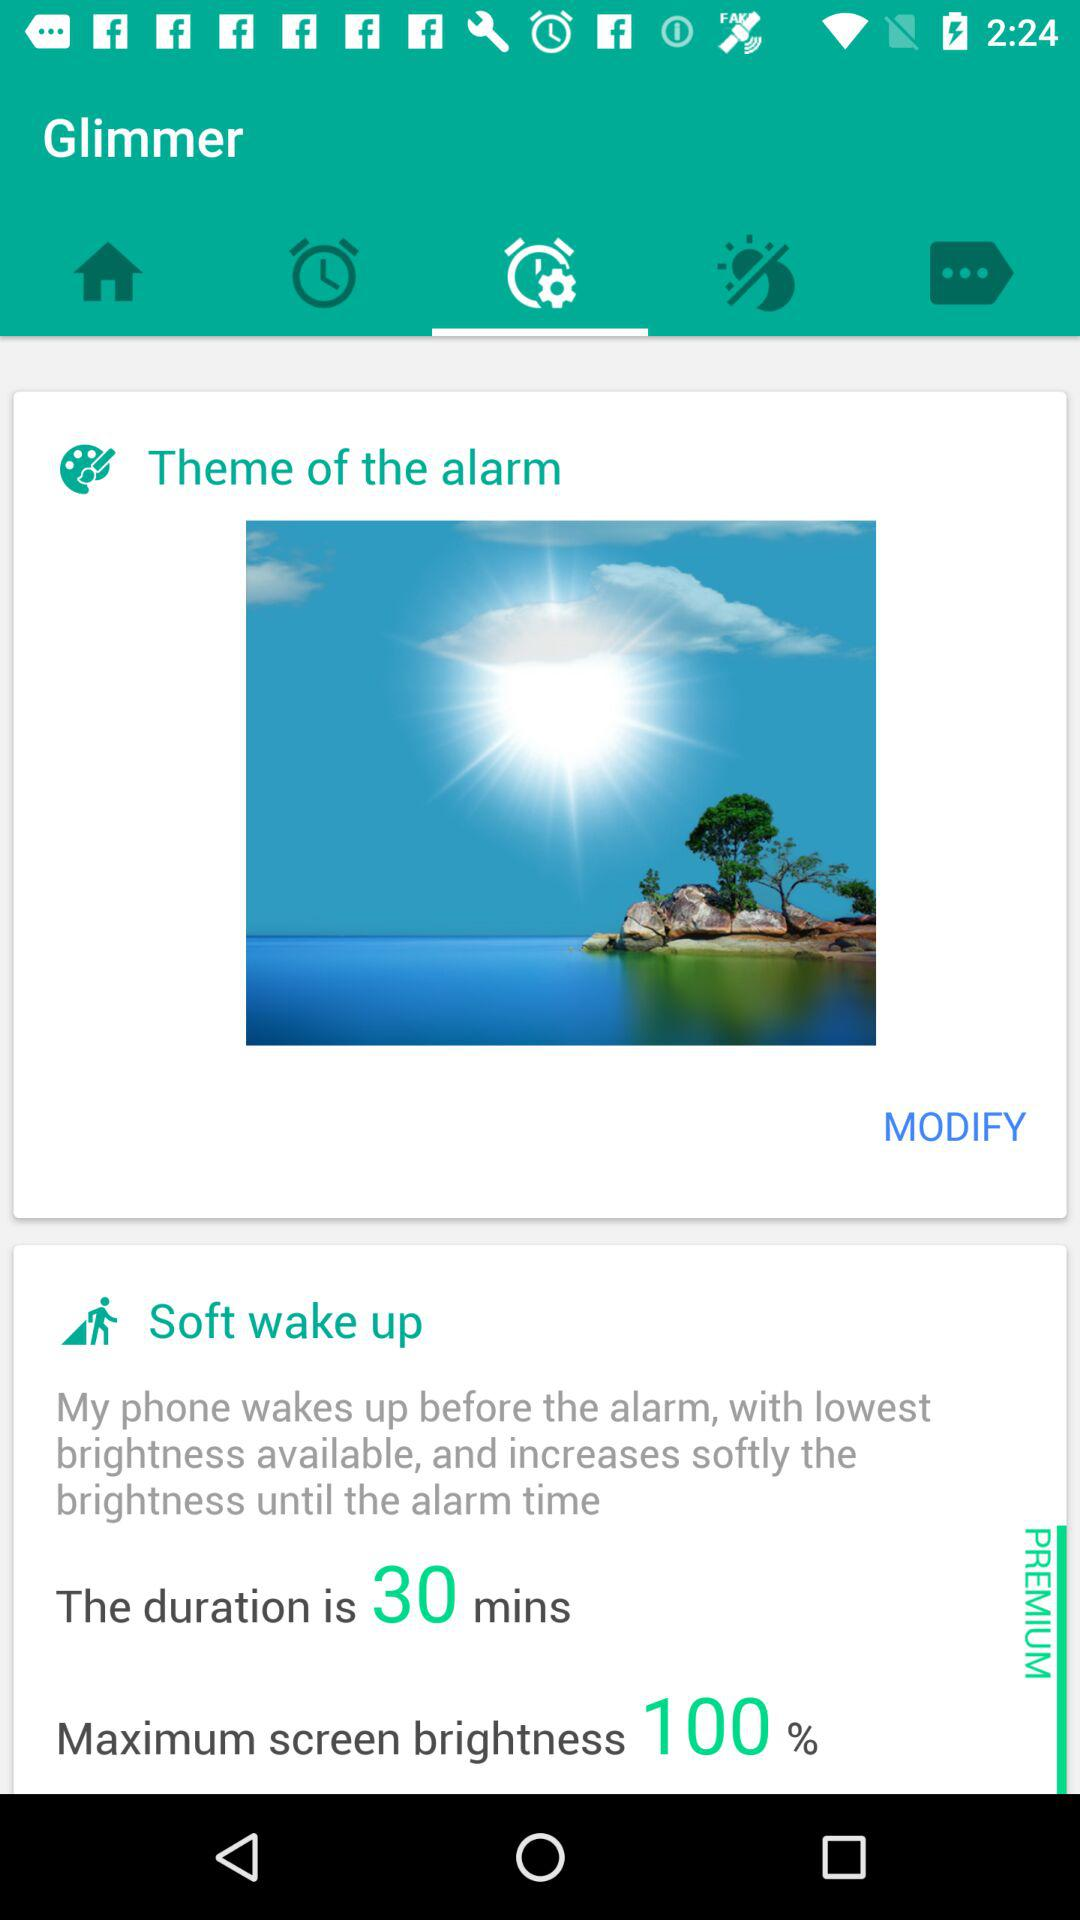What is the maximum screen brightness percentage? The maximum screen brightness is 100%. 